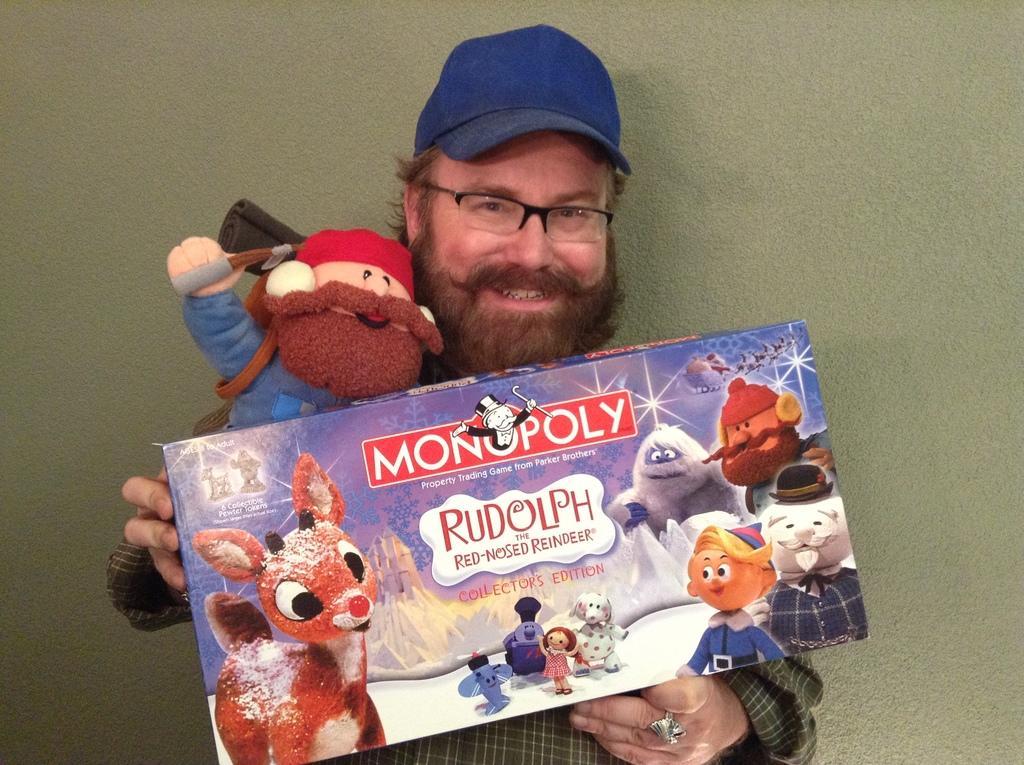Can you describe this image briefly? In this image there is a man with cap standing holding doll and packet. 